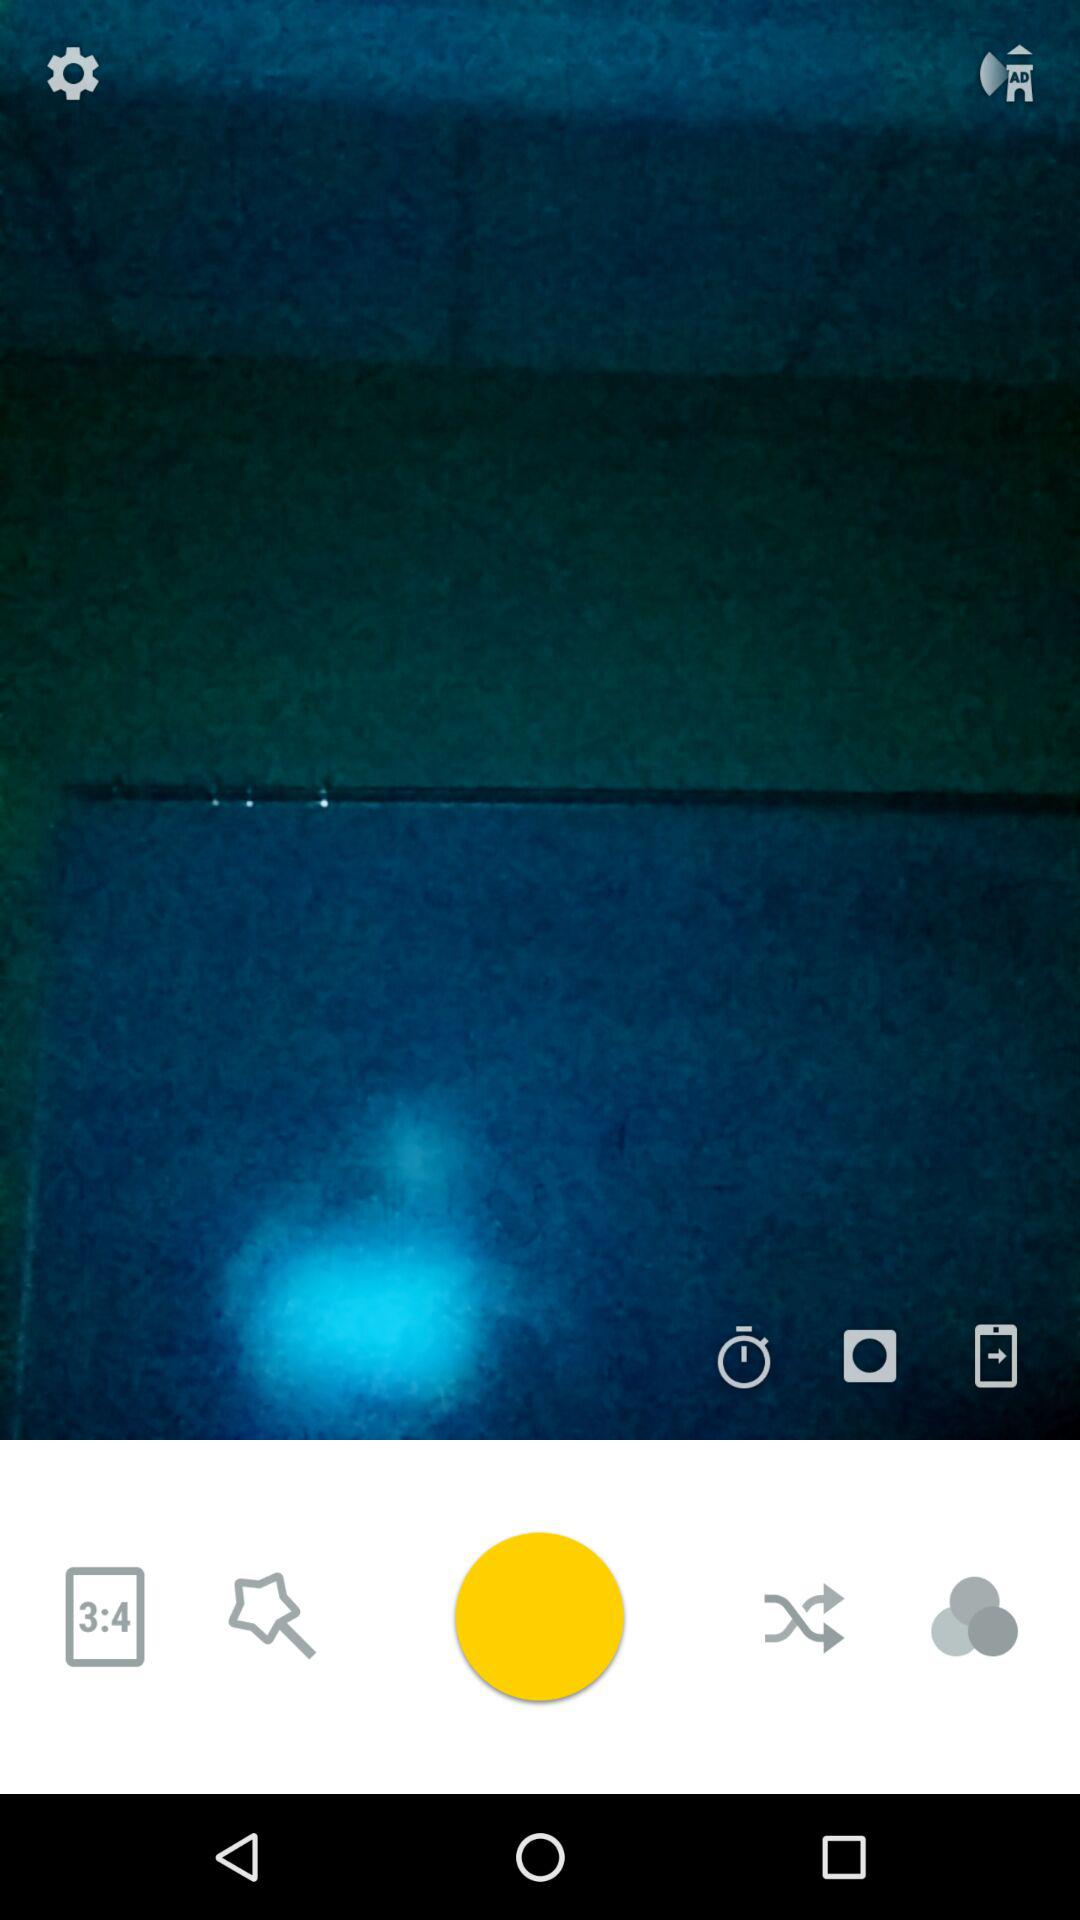How many circles are on the screen?
Answer the question using a single word or phrase. 4 